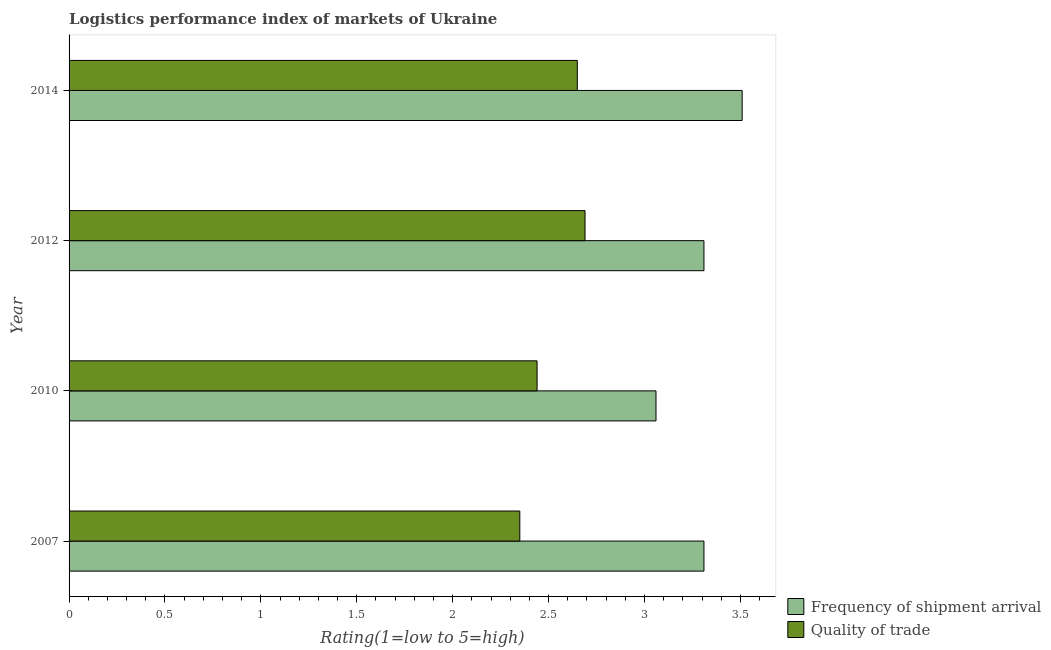How many groups of bars are there?
Make the answer very short. 4. What is the lpi of frequency of shipment arrival in 2014?
Your answer should be compact. 3.51. Across all years, what is the maximum lpi of frequency of shipment arrival?
Provide a short and direct response. 3.51. Across all years, what is the minimum lpi quality of trade?
Your response must be concise. 2.35. In which year was the lpi quality of trade minimum?
Your answer should be compact. 2007. What is the total lpi of frequency of shipment arrival in the graph?
Offer a terse response. 13.19. What is the difference between the lpi of frequency of shipment arrival in 2007 and that in 2014?
Your response must be concise. -0.2. What is the average lpi of frequency of shipment arrival per year?
Your answer should be compact. 3.3. In the year 2012, what is the difference between the lpi of frequency of shipment arrival and lpi quality of trade?
Ensure brevity in your answer.  0.62. What is the ratio of the lpi of frequency of shipment arrival in 2007 to that in 2014?
Your response must be concise. 0.94. Is the difference between the lpi quality of trade in 2007 and 2012 greater than the difference between the lpi of frequency of shipment arrival in 2007 and 2012?
Keep it short and to the point. No. What is the difference between the highest and the second highest lpi of frequency of shipment arrival?
Your response must be concise. 0.2. What is the difference between the highest and the lowest lpi of frequency of shipment arrival?
Provide a succinct answer. 0.45. In how many years, is the lpi quality of trade greater than the average lpi quality of trade taken over all years?
Offer a very short reply. 2. What does the 1st bar from the top in 2014 represents?
Provide a succinct answer. Quality of trade. What does the 2nd bar from the bottom in 2012 represents?
Your answer should be compact. Quality of trade. How are the legend labels stacked?
Your response must be concise. Vertical. What is the title of the graph?
Your response must be concise. Logistics performance index of markets of Ukraine. What is the label or title of the X-axis?
Your response must be concise. Rating(1=low to 5=high). What is the label or title of the Y-axis?
Your response must be concise. Year. What is the Rating(1=low to 5=high) of Frequency of shipment arrival in 2007?
Ensure brevity in your answer.  3.31. What is the Rating(1=low to 5=high) of Quality of trade in 2007?
Keep it short and to the point. 2.35. What is the Rating(1=low to 5=high) in Frequency of shipment arrival in 2010?
Your answer should be compact. 3.06. What is the Rating(1=low to 5=high) in Quality of trade in 2010?
Keep it short and to the point. 2.44. What is the Rating(1=low to 5=high) in Frequency of shipment arrival in 2012?
Offer a very short reply. 3.31. What is the Rating(1=low to 5=high) in Quality of trade in 2012?
Provide a short and direct response. 2.69. What is the Rating(1=low to 5=high) in Frequency of shipment arrival in 2014?
Offer a very short reply. 3.51. What is the Rating(1=low to 5=high) of Quality of trade in 2014?
Your answer should be compact. 2.65. Across all years, what is the maximum Rating(1=low to 5=high) of Frequency of shipment arrival?
Ensure brevity in your answer.  3.51. Across all years, what is the maximum Rating(1=low to 5=high) in Quality of trade?
Your answer should be compact. 2.69. Across all years, what is the minimum Rating(1=low to 5=high) in Frequency of shipment arrival?
Your answer should be compact. 3.06. Across all years, what is the minimum Rating(1=low to 5=high) of Quality of trade?
Offer a terse response. 2.35. What is the total Rating(1=low to 5=high) in Frequency of shipment arrival in the graph?
Keep it short and to the point. 13.19. What is the total Rating(1=low to 5=high) of Quality of trade in the graph?
Make the answer very short. 10.13. What is the difference between the Rating(1=low to 5=high) in Quality of trade in 2007 and that in 2010?
Keep it short and to the point. -0.09. What is the difference between the Rating(1=low to 5=high) in Quality of trade in 2007 and that in 2012?
Provide a short and direct response. -0.34. What is the difference between the Rating(1=low to 5=high) of Frequency of shipment arrival in 2007 and that in 2014?
Offer a terse response. -0.2. What is the difference between the Rating(1=low to 5=high) in Quality of trade in 2007 and that in 2014?
Make the answer very short. -0.3. What is the difference between the Rating(1=low to 5=high) of Quality of trade in 2010 and that in 2012?
Your response must be concise. -0.25. What is the difference between the Rating(1=low to 5=high) in Frequency of shipment arrival in 2010 and that in 2014?
Make the answer very short. -0.45. What is the difference between the Rating(1=low to 5=high) in Quality of trade in 2010 and that in 2014?
Your answer should be compact. -0.21. What is the difference between the Rating(1=low to 5=high) of Frequency of shipment arrival in 2012 and that in 2014?
Provide a short and direct response. -0.2. What is the difference between the Rating(1=low to 5=high) in Quality of trade in 2012 and that in 2014?
Offer a very short reply. 0.04. What is the difference between the Rating(1=low to 5=high) in Frequency of shipment arrival in 2007 and the Rating(1=low to 5=high) in Quality of trade in 2010?
Your answer should be very brief. 0.87. What is the difference between the Rating(1=low to 5=high) in Frequency of shipment arrival in 2007 and the Rating(1=low to 5=high) in Quality of trade in 2012?
Your response must be concise. 0.62. What is the difference between the Rating(1=low to 5=high) of Frequency of shipment arrival in 2007 and the Rating(1=low to 5=high) of Quality of trade in 2014?
Provide a short and direct response. 0.66. What is the difference between the Rating(1=low to 5=high) of Frequency of shipment arrival in 2010 and the Rating(1=low to 5=high) of Quality of trade in 2012?
Offer a terse response. 0.37. What is the difference between the Rating(1=low to 5=high) in Frequency of shipment arrival in 2010 and the Rating(1=low to 5=high) in Quality of trade in 2014?
Your answer should be very brief. 0.41. What is the difference between the Rating(1=low to 5=high) of Frequency of shipment arrival in 2012 and the Rating(1=low to 5=high) of Quality of trade in 2014?
Your answer should be very brief. 0.66. What is the average Rating(1=low to 5=high) of Frequency of shipment arrival per year?
Your response must be concise. 3.3. What is the average Rating(1=low to 5=high) of Quality of trade per year?
Your answer should be very brief. 2.53. In the year 2010, what is the difference between the Rating(1=low to 5=high) of Frequency of shipment arrival and Rating(1=low to 5=high) of Quality of trade?
Offer a terse response. 0.62. In the year 2012, what is the difference between the Rating(1=low to 5=high) of Frequency of shipment arrival and Rating(1=low to 5=high) of Quality of trade?
Offer a very short reply. 0.62. In the year 2014, what is the difference between the Rating(1=low to 5=high) in Frequency of shipment arrival and Rating(1=low to 5=high) in Quality of trade?
Offer a very short reply. 0.86. What is the ratio of the Rating(1=low to 5=high) of Frequency of shipment arrival in 2007 to that in 2010?
Provide a short and direct response. 1.08. What is the ratio of the Rating(1=low to 5=high) in Quality of trade in 2007 to that in 2010?
Offer a very short reply. 0.96. What is the ratio of the Rating(1=low to 5=high) of Quality of trade in 2007 to that in 2012?
Offer a terse response. 0.87. What is the ratio of the Rating(1=low to 5=high) in Frequency of shipment arrival in 2007 to that in 2014?
Your answer should be compact. 0.94. What is the ratio of the Rating(1=low to 5=high) in Quality of trade in 2007 to that in 2014?
Make the answer very short. 0.89. What is the ratio of the Rating(1=low to 5=high) in Frequency of shipment arrival in 2010 to that in 2012?
Offer a very short reply. 0.92. What is the ratio of the Rating(1=low to 5=high) of Quality of trade in 2010 to that in 2012?
Make the answer very short. 0.91. What is the ratio of the Rating(1=low to 5=high) of Frequency of shipment arrival in 2010 to that in 2014?
Your response must be concise. 0.87. What is the ratio of the Rating(1=low to 5=high) of Quality of trade in 2010 to that in 2014?
Your answer should be compact. 0.92. What is the ratio of the Rating(1=low to 5=high) in Frequency of shipment arrival in 2012 to that in 2014?
Ensure brevity in your answer.  0.94. What is the ratio of the Rating(1=low to 5=high) in Quality of trade in 2012 to that in 2014?
Offer a terse response. 1.02. What is the difference between the highest and the second highest Rating(1=low to 5=high) in Frequency of shipment arrival?
Offer a terse response. 0.2. What is the difference between the highest and the second highest Rating(1=low to 5=high) of Quality of trade?
Provide a succinct answer. 0.04. What is the difference between the highest and the lowest Rating(1=low to 5=high) of Frequency of shipment arrival?
Offer a very short reply. 0.45. What is the difference between the highest and the lowest Rating(1=low to 5=high) of Quality of trade?
Your response must be concise. 0.34. 